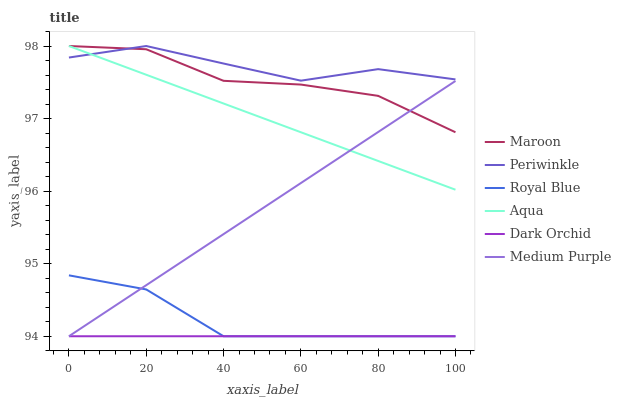Does Dark Orchid have the minimum area under the curve?
Answer yes or no. Yes. Does Periwinkle have the maximum area under the curve?
Answer yes or no. Yes. Does Medium Purple have the minimum area under the curve?
Answer yes or no. No. Does Medium Purple have the maximum area under the curve?
Answer yes or no. No. Is Dark Orchid the smoothest?
Answer yes or no. Yes. Is Maroon the roughest?
Answer yes or no. Yes. Is Medium Purple the smoothest?
Answer yes or no. No. Is Medium Purple the roughest?
Answer yes or no. No. Does Dark Orchid have the lowest value?
Answer yes or no. Yes. Does Periwinkle have the lowest value?
Answer yes or no. No. Does Maroon have the highest value?
Answer yes or no. Yes. Does Medium Purple have the highest value?
Answer yes or no. No. Is Medium Purple less than Periwinkle?
Answer yes or no. Yes. Is Periwinkle greater than Medium Purple?
Answer yes or no. Yes. Does Maroon intersect Periwinkle?
Answer yes or no. Yes. Is Maroon less than Periwinkle?
Answer yes or no. No. Is Maroon greater than Periwinkle?
Answer yes or no. No. Does Medium Purple intersect Periwinkle?
Answer yes or no. No. 